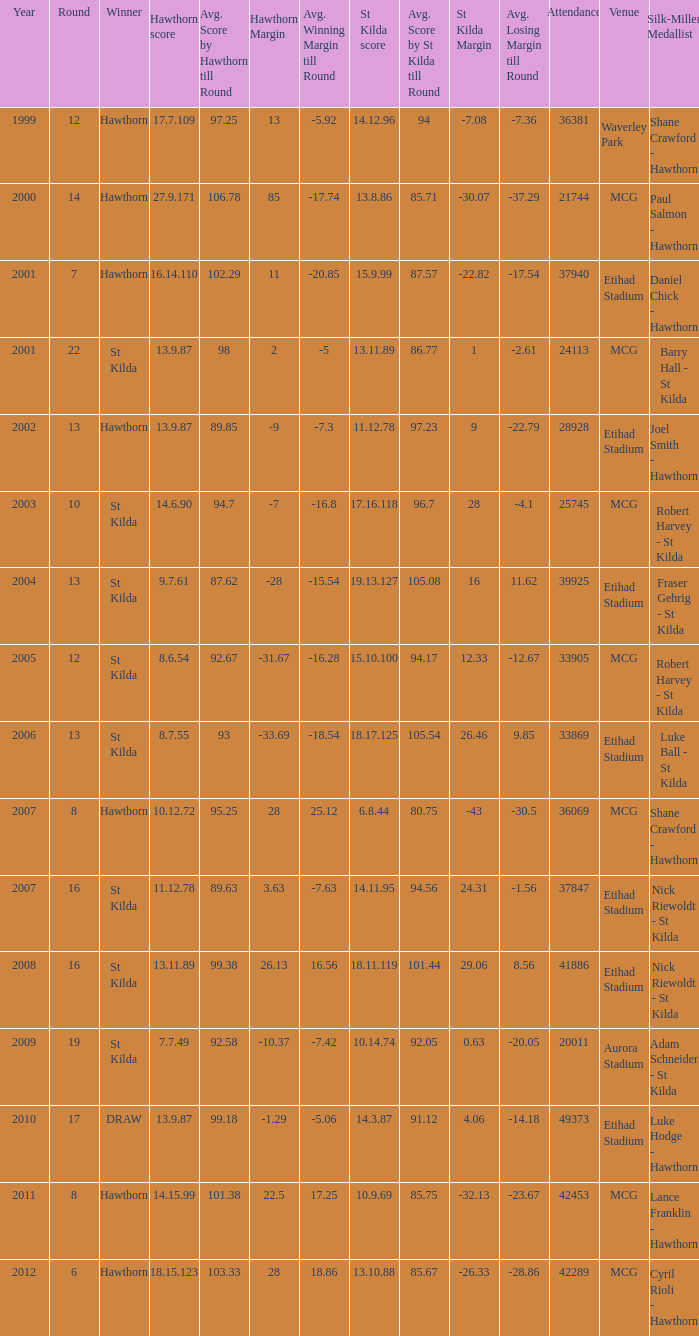Who is the winner when the st kilda score is 13.10.88? Hawthorn. 